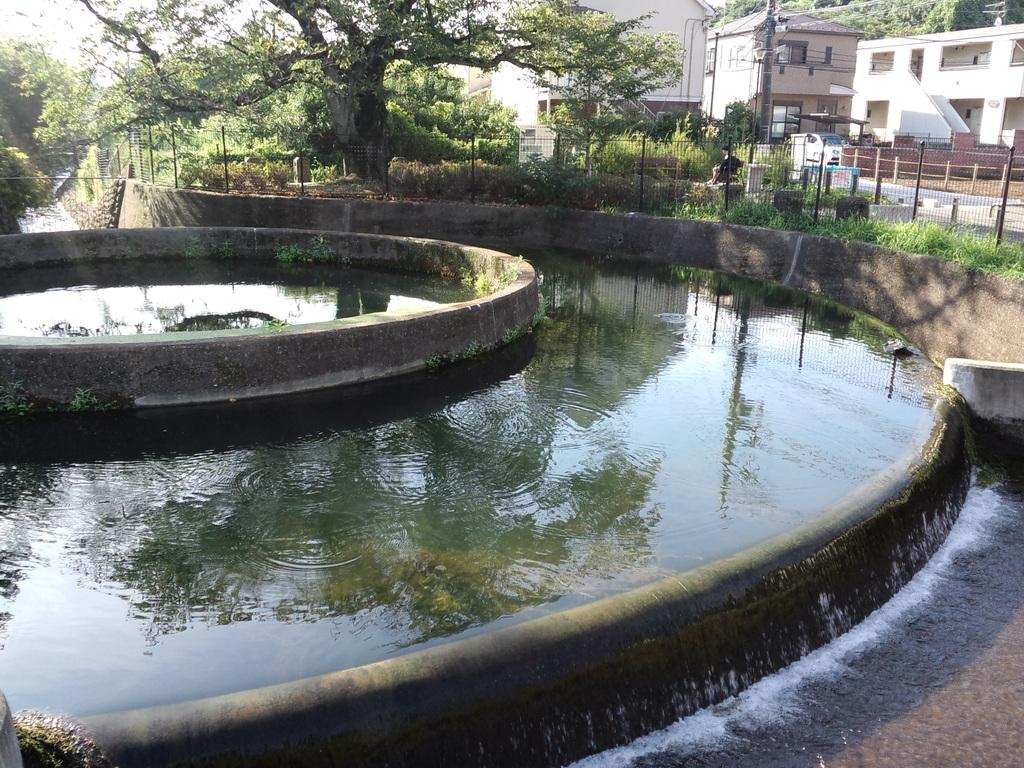What is in the front of the image? There is water in the front of the image. What can be seen in the background of the image? In the background of the image, there is fencing, grass, bushes, trees, and buildings. Can you describe the vegetation in the background of the image? The vegetation in the background includes grass, bushes, and trees. Are there any structures visible in the background of the image? Yes, there are buildings in the background of the image. Is there any sign of human presence in the image? Yes, there is a person near the buildings in the background of the image. What type of mint is growing near the water in the image? There is no mint present in the image; it only features water, fencing, grass, bushes, trees, buildings, and a person. How does the dust affect the visibility of the buildings in the image? There is no mention of dust in the image, and the visibility of the buildings is not affected by any dust. 